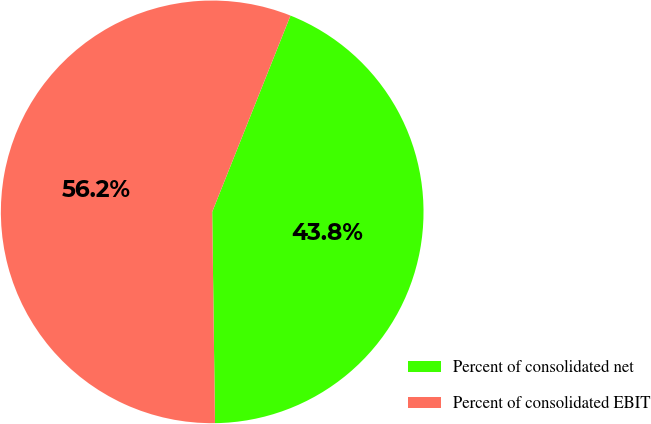Convert chart to OTSL. <chart><loc_0><loc_0><loc_500><loc_500><pie_chart><fcel>Percent of consolidated net<fcel>Percent of consolidated EBIT<nl><fcel>43.75%<fcel>56.25%<nl></chart> 